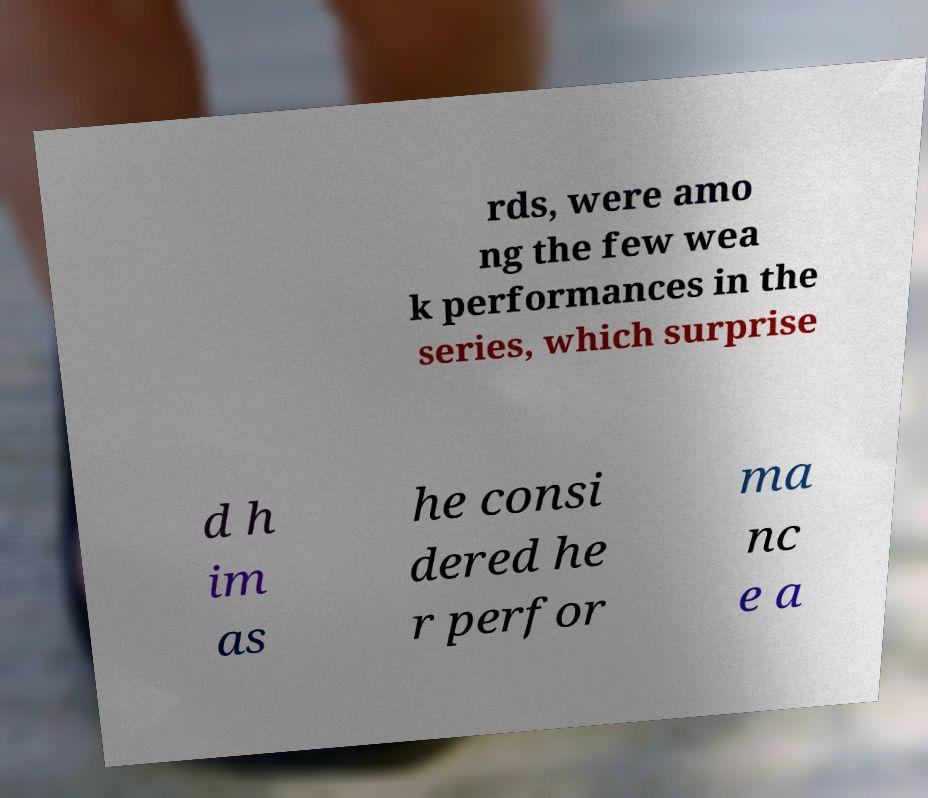I need the written content from this picture converted into text. Can you do that? rds, were amo ng the few wea k performances in the series, which surprise d h im as he consi dered he r perfor ma nc e a 